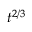Convert formula to latex. <formula><loc_0><loc_0><loc_500><loc_500>t ^ { 2 / 3 }</formula> 